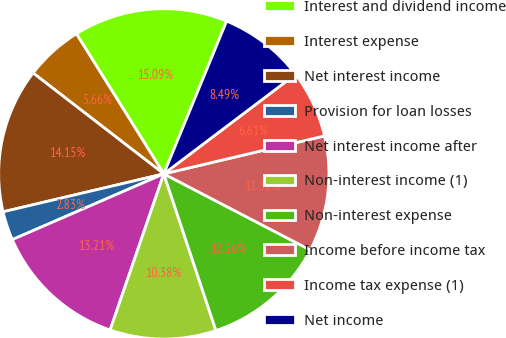Convert chart. <chart><loc_0><loc_0><loc_500><loc_500><pie_chart><fcel>Interest and dividend income<fcel>Interest expense<fcel>Net interest income<fcel>Provision for loan losses<fcel>Net interest income after<fcel>Non-interest income (1)<fcel>Non-interest expense<fcel>Income before income tax<fcel>Income tax expense (1)<fcel>Net income<nl><fcel>15.09%<fcel>5.66%<fcel>14.15%<fcel>2.83%<fcel>13.21%<fcel>10.38%<fcel>12.26%<fcel>11.32%<fcel>6.61%<fcel>8.49%<nl></chart> 